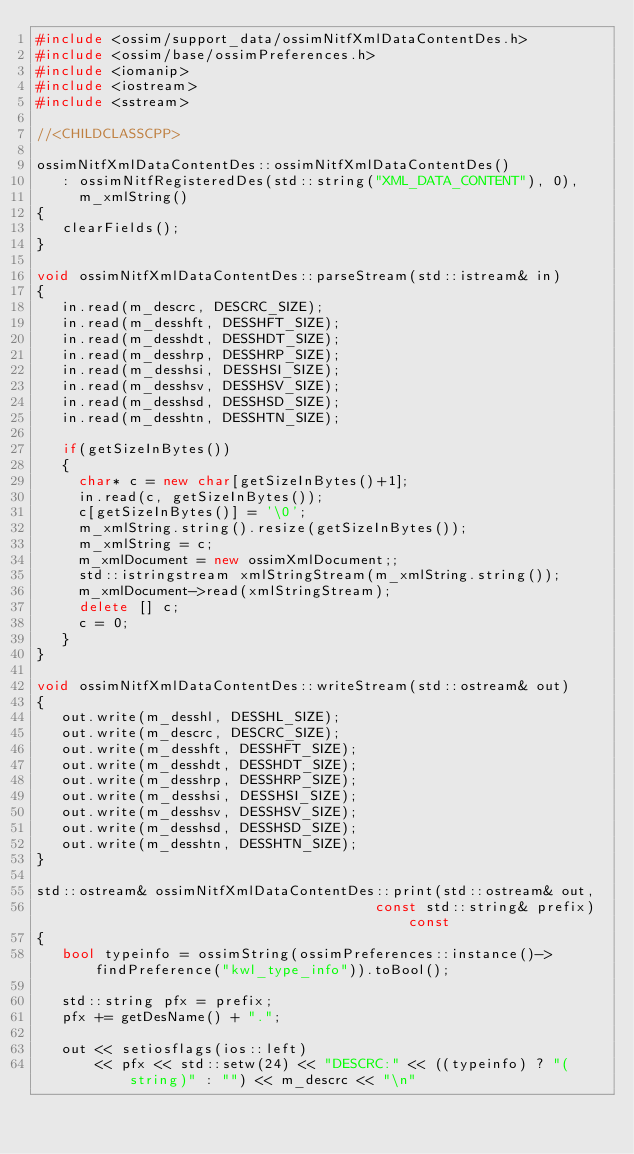<code> <loc_0><loc_0><loc_500><loc_500><_C++_>#include <ossim/support_data/ossimNitfXmlDataContentDes.h>
#include <ossim/base/ossimPreferences.h>
#include <iomanip>
#include <iostream>
#include <sstream>

//<CHILDCLASSCPP>

ossimNitfXmlDataContentDes::ossimNitfXmlDataContentDes()
   : ossimNitfRegisteredDes(std::string("XML_DATA_CONTENT"), 0),
     m_xmlString()
{
   clearFields();
}

void ossimNitfXmlDataContentDes::parseStream(std::istream& in)
{
   in.read(m_descrc, DESCRC_SIZE);
   in.read(m_desshft, DESSHFT_SIZE);
   in.read(m_desshdt, DESSHDT_SIZE);
   in.read(m_desshrp, DESSHRP_SIZE);
   in.read(m_desshsi, DESSHSI_SIZE);
   in.read(m_desshsv, DESSHSV_SIZE);
   in.read(m_desshsd, DESSHSD_SIZE);
   in.read(m_desshtn, DESSHTN_SIZE);

   if(getSizeInBytes())
   {
     char* c = new char[getSizeInBytes()+1];
     in.read(c, getSizeInBytes());
     c[getSizeInBytes()] = '\0';
     m_xmlString.string().resize(getSizeInBytes());
     m_xmlString = c;
     m_xmlDocument = new ossimXmlDocument;;
     std::istringstream xmlStringStream(m_xmlString.string());
     m_xmlDocument->read(xmlStringStream);
     delete [] c;
     c = 0;
   }
}

void ossimNitfXmlDataContentDes::writeStream(std::ostream& out)
{
   out.write(m_desshl, DESSHL_SIZE);
   out.write(m_descrc, DESCRC_SIZE);
   out.write(m_desshft, DESSHFT_SIZE);
   out.write(m_desshdt, DESSHDT_SIZE);
   out.write(m_desshrp, DESSHRP_SIZE);
   out.write(m_desshsi, DESSHSI_SIZE);
   out.write(m_desshsv, DESSHSV_SIZE);
   out.write(m_desshsd, DESSHSD_SIZE);
   out.write(m_desshtn, DESSHTN_SIZE);
}

std::ostream& ossimNitfXmlDataContentDes::print(std::ostream& out,
                                        const std::string& prefix) const
{
   bool typeinfo = ossimString(ossimPreferences::instance()->findPreference("kwl_type_info")).toBool();

   std::string pfx = prefix;
   pfx += getDesName() + ".";
   
   out << setiosflags(ios::left)
       << pfx << std::setw(24) << "DESCRC:" << ((typeinfo) ? "(string)" : "") << m_descrc << "\n"</code> 